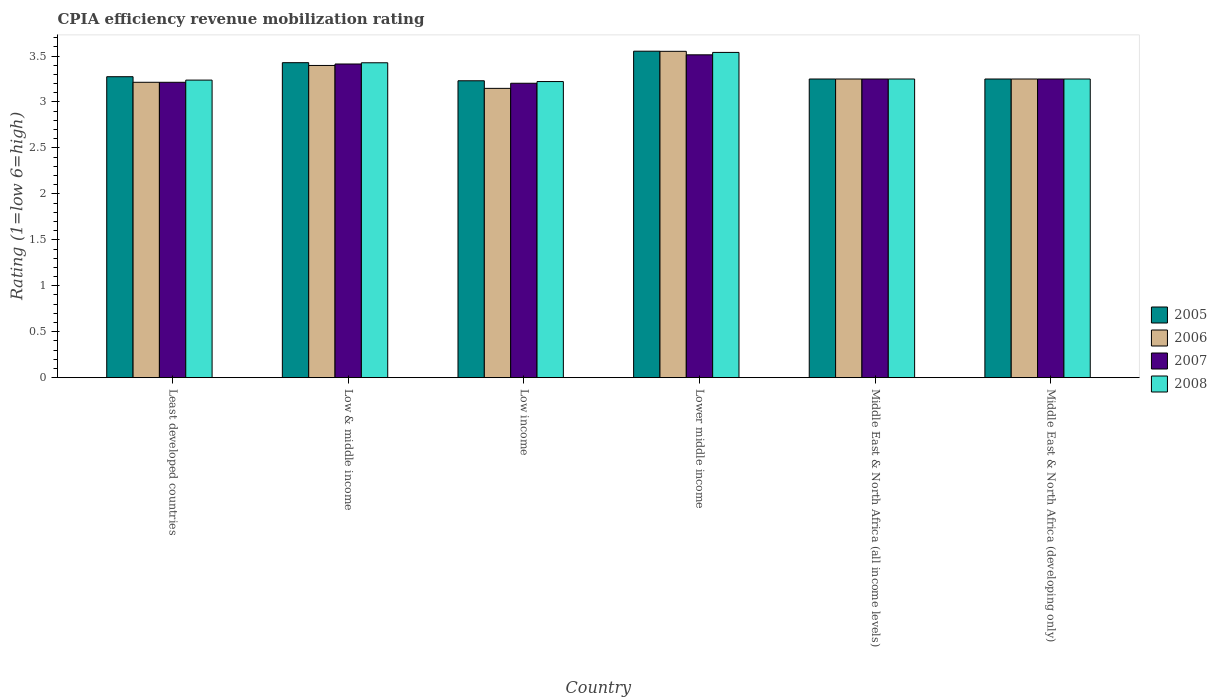How many different coloured bars are there?
Your response must be concise. 4. How many groups of bars are there?
Ensure brevity in your answer.  6. How many bars are there on the 4th tick from the left?
Provide a short and direct response. 4. What is the label of the 5th group of bars from the left?
Your answer should be very brief. Middle East & North Africa (all income levels). What is the CPIA rating in 2005 in Lower middle income?
Give a very brief answer. 3.55. Across all countries, what is the maximum CPIA rating in 2008?
Give a very brief answer. 3.54. Across all countries, what is the minimum CPIA rating in 2008?
Keep it short and to the point. 3.22. In which country was the CPIA rating in 2007 maximum?
Ensure brevity in your answer.  Lower middle income. What is the total CPIA rating in 2008 in the graph?
Your answer should be very brief. 19.93. What is the difference between the CPIA rating in 2005 in Low income and that in Lower middle income?
Your answer should be very brief. -0.32. What is the difference between the CPIA rating in 2005 in Least developed countries and the CPIA rating in 2008 in Middle East & North Africa (all income levels)?
Give a very brief answer. 0.02. What is the average CPIA rating in 2007 per country?
Provide a short and direct response. 3.31. In how many countries, is the CPIA rating in 2005 greater than 0.6?
Give a very brief answer. 6. What is the ratio of the CPIA rating in 2008 in Least developed countries to that in Lower middle income?
Make the answer very short. 0.91. Is the CPIA rating in 2007 in Low income less than that in Lower middle income?
Your answer should be very brief. Yes. What is the difference between the highest and the second highest CPIA rating in 2006?
Your answer should be very brief. 0.15. What is the difference between the highest and the lowest CPIA rating in 2008?
Your answer should be compact. 0.32. In how many countries, is the CPIA rating in 2008 greater than the average CPIA rating in 2008 taken over all countries?
Provide a succinct answer. 2. Is it the case that in every country, the sum of the CPIA rating in 2008 and CPIA rating in 2007 is greater than the sum of CPIA rating in 2006 and CPIA rating in 2005?
Your answer should be very brief. No. What does the 3rd bar from the left in Least developed countries represents?
Make the answer very short. 2007. Is it the case that in every country, the sum of the CPIA rating in 2008 and CPIA rating in 2007 is greater than the CPIA rating in 2006?
Your response must be concise. Yes. How many countries are there in the graph?
Offer a terse response. 6. Does the graph contain any zero values?
Offer a very short reply. No. How many legend labels are there?
Your answer should be compact. 4. What is the title of the graph?
Your answer should be compact. CPIA efficiency revenue mobilization rating. What is the Rating (1=low 6=high) of 2005 in Least developed countries?
Keep it short and to the point. 3.27. What is the Rating (1=low 6=high) in 2006 in Least developed countries?
Offer a terse response. 3.21. What is the Rating (1=low 6=high) of 2007 in Least developed countries?
Provide a short and direct response. 3.21. What is the Rating (1=low 6=high) in 2008 in Least developed countries?
Provide a succinct answer. 3.24. What is the Rating (1=low 6=high) in 2005 in Low & middle income?
Provide a short and direct response. 3.43. What is the Rating (1=low 6=high) in 2006 in Low & middle income?
Your response must be concise. 3.4. What is the Rating (1=low 6=high) in 2007 in Low & middle income?
Your response must be concise. 3.41. What is the Rating (1=low 6=high) in 2008 in Low & middle income?
Your answer should be very brief. 3.43. What is the Rating (1=low 6=high) in 2005 in Low income?
Offer a terse response. 3.23. What is the Rating (1=low 6=high) in 2006 in Low income?
Give a very brief answer. 3.15. What is the Rating (1=low 6=high) in 2007 in Low income?
Your answer should be compact. 3.2. What is the Rating (1=low 6=high) in 2008 in Low income?
Provide a short and direct response. 3.22. What is the Rating (1=low 6=high) of 2005 in Lower middle income?
Your answer should be compact. 3.55. What is the Rating (1=low 6=high) of 2006 in Lower middle income?
Your answer should be compact. 3.55. What is the Rating (1=low 6=high) in 2007 in Lower middle income?
Provide a succinct answer. 3.51. What is the Rating (1=low 6=high) in 2008 in Lower middle income?
Ensure brevity in your answer.  3.54. What is the Rating (1=low 6=high) in 2005 in Middle East & North Africa (all income levels)?
Provide a succinct answer. 3.25. What is the Rating (1=low 6=high) of 2006 in Middle East & North Africa (all income levels)?
Ensure brevity in your answer.  3.25. What is the Rating (1=low 6=high) in 2007 in Middle East & North Africa (all income levels)?
Keep it short and to the point. 3.25. What is the Rating (1=low 6=high) of 2007 in Middle East & North Africa (developing only)?
Offer a very short reply. 3.25. Across all countries, what is the maximum Rating (1=low 6=high) of 2005?
Your response must be concise. 3.55. Across all countries, what is the maximum Rating (1=low 6=high) of 2006?
Ensure brevity in your answer.  3.55. Across all countries, what is the maximum Rating (1=low 6=high) in 2007?
Provide a succinct answer. 3.51. Across all countries, what is the maximum Rating (1=low 6=high) of 2008?
Give a very brief answer. 3.54. Across all countries, what is the minimum Rating (1=low 6=high) in 2005?
Your answer should be compact. 3.23. Across all countries, what is the minimum Rating (1=low 6=high) of 2006?
Your response must be concise. 3.15. Across all countries, what is the minimum Rating (1=low 6=high) of 2007?
Ensure brevity in your answer.  3.2. Across all countries, what is the minimum Rating (1=low 6=high) of 2008?
Keep it short and to the point. 3.22. What is the total Rating (1=low 6=high) of 2005 in the graph?
Give a very brief answer. 19.99. What is the total Rating (1=low 6=high) in 2006 in the graph?
Your answer should be compact. 19.81. What is the total Rating (1=low 6=high) of 2007 in the graph?
Give a very brief answer. 19.84. What is the total Rating (1=low 6=high) of 2008 in the graph?
Provide a short and direct response. 19.93. What is the difference between the Rating (1=low 6=high) of 2005 in Least developed countries and that in Low & middle income?
Your response must be concise. -0.15. What is the difference between the Rating (1=low 6=high) in 2006 in Least developed countries and that in Low & middle income?
Give a very brief answer. -0.18. What is the difference between the Rating (1=low 6=high) of 2007 in Least developed countries and that in Low & middle income?
Provide a short and direct response. -0.2. What is the difference between the Rating (1=low 6=high) of 2008 in Least developed countries and that in Low & middle income?
Ensure brevity in your answer.  -0.19. What is the difference between the Rating (1=low 6=high) in 2005 in Least developed countries and that in Low income?
Provide a succinct answer. 0.04. What is the difference between the Rating (1=low 6=high) of 2006 in Least developed countries and that in Low income?
Provide a short and direct response. 0.07. What is the difference between the Rating (1=low 6=high) of 2007 in Least developed countries and that in Low income?
Ensure brevity in your answer.  0.01. What is the difference between the Rating (1=low 6=high) in 2008 in Least developed countries and that in Low income?
Your response must be concise. 0.02. What is the difference between the Rating (1=low 6=high) in 2005 in Least developed countries and that in Lower middle income?
Offer a terse response. -0.28. What is the difference between the Rating (1=low 6=high) of 2006 in Least developed countries and that in Lower middle income?
Your response must be concise. -0.34. What is the difference between the Rating (1=low 6=high) in 2007 in Least developed countries and that in Lower middle income?
Your response must be concise. -0.3. What is the difference between the Rating (1=low 6=high) in 2008 in Least developed countries and that in Lower middle income?
Offer a terse response. -0.3. What is the difference between the Rating (1=low 6=high) of 2005 in Least developed countries and that in Middle East & North Africa (all income levels)?
Provide a succinct answer. 0.03. What is the difference between the Rating (1=low 6=high) in 2006 in Least developed countries and that in Middle East & North Africa (all income levels)?
Keep it short and to the point. -0.04. What is the difference between the Rating (1=low 6=high) in 2007 in Least developed countries and that in Middle East & North Africa (all income levels)?
Your answer should be compact. -0.04. What is the difference between the Rating (1=low 6=high) in 2008 in Least developed countries and that in Middle East & North Africa (all income levels)?
Ensure brevity in your answer.  -0.01. What is the difference between the Rating (1=low 6=high) in 2005 in Least developed countries and that in Middle East & North Africa (developing only)?
Provide a short and direct response. 0.03. What is the difference between the Rating (1=low 6=high) in 2006 in Least developed countries and that in Middle East & North Africa (developing only)?
Make the answer very short. -0.04. What is the difference between the Rating (1=low 6=high) in 2007 in Least developed countries and that in Middle East & North Africa (developing only)?
Make the answer very short. -0.04. What is the difference between the Rating (1=low 6=high) in 2008 in Least developed countries and that in Middle East & North Africa (developing only)?
Keep it short and to the point. -0.01. What is the difference between the Rating (1=low 6=high) in 2005 in Low & middle income and that in Low income?
Your response must be concise. 0.2. What is the difference between the Rating (1=low 6=high) of 2006 in Low & middle income and that in Low income?
Give a very brief answer. 0.25. What is the difference between the Rating (1=low 6=high) of 2007 in Low & middle income and that in Low income?
Provide a succinct answer. 0.21. What is the difference between the Rating (1=low 6=high) of 2008 in Low & middle income and that in Low income?
Provide a succinct answer. 0.2. What is the difference between the Rating (1=low 6=high) in 2005 in Low & middle income and that in Lower middle income?
Your answer should be very brief. -0.12. What is the difference between the Rating (1=low 6=high) of 2006 in Low & middle income and that in Lower middle income?
Provide a short and direct response. -0.15. What is the difference between the Rating (1=low 6=high) in 2007 in Low & middle income and that in Lower middle income?
Offer a terse response. -0.1. What is the difference between the Rating (1=low 6=high) of 2008 in Low & middle income and that in Lower middle income?
Ensure brevity in your answer.  -0.11. What is the difference between the Rating (1=low 6=high) in 2005 in Low & middle income and that in Middle East & North Africa (all income levels)?
Keep it short and to the point. 0.18. What is the difference between the Rating (1=low 6=high) of 2006 in Low & middle income and that in Middle East & North Africa (all income levels)?
Keep it short and to the point. 0.15. What is the difference between the Rating (1=low 6=high) in 2007 in Low & middle income and that in Middle East & North Africa (all income levels)?
Your response must be concise. 0.16. What is the difference between the Rating (1=low 6=high) in 2008 in Low & middle income and that in Middle East & North Africa (all income levels)?
Your response must be concise. 0.18. What is the difference between the Rating (1=low 6=high) of 2005 in Low & middle income and that in Middle East & North Africa (developing only)?
Ensure brevity in your answer.  0.18. What is the difference between the Rating (1=low 6=high) in 2006 in Low & middle income and that in Middle East & North Africa (developing only)?
Provide a short and direct response. 0.15. What is the difference between the Rating (1=low 6=high) of 2007 in Low & middle income and that in Middle East & North Africa (developing only)?
Make the answer very short. 0.16. What is the difference between the Rating (1=low 6=high) of 2008 in Low & middle income and that in Middle East & North Africa (developing only)?
Offer a terse response. 0.18. What is the difference between the Rating (1=low 6=high) of 2005 in Low income and that in Lower middle income?
Keep it short and to the point. -0.32. What is the difference between the Rating (1=low 6=high) in 2006 in Low income and that in Lower middle income?
Give a very brief answer. -0.4. What is the difference between the Rating (1=low 6=high) in 2007 in Low income and that in Lower middle income?
Make the answer very short. -0.31. What is the difference between the Rating (1=low 6=high) in 2008 in Low income and that in Lower middle income?
Your answer should be compact. -0.32. What is the difference between the Rating (1=low 6=high) in 2005 in Low income and that in Middle East & North Africa (all income levels)?
Provide a succinct answer. -0.02. What is the difference between the Rating (1=low 6=high) of 2006 in Low income and that in Middle East & North Africa (all income levels)?
Your answer should be very brief. -0.1. What is the difference between the Rating (1=low 6=high) of 2007 in Low income and that in Middle East & North Africa (all income levels)?
Provide a succinct answer. -0.05. What is the difference between the Rating (1=low 6=high) in 2008 in Low income and that in Middle East & North Africa (all income levels)?
Your response must be concise. -0.03. What is the difference between the Rating (1=low 6=high) of 2005 in Low income and that in Middle East & North Africa (developing only)?
Ensure brevity in your answer.  -0.02. What is the difference between the Rating (1=low 6=high) of 2006 in Low income and that in Middle East & North Africa (developing only)?
Provide a short and direct response. -0.1. What is the difference between the Rating (1=low 6=high) in 2007 in Low income and that in Middle East & North Africa (developing only)?
Your answer should be compact. -0.05. What is the difference between the Rating (1=low 6=high) in 2008 in Low income and that in Middle East & North Africa (developing only)?
Make the answer very short. -0.03. What is the difference between the Rating (1=low 6=high) in 2005 in Lower middle income and that in Middle East & North Africa (all income levels)?
Your response must be concise. 0.3. What is the difference between the Rating (1=low 6=high) in 2006 in Lower middle income and that in Middle East & North Africa (all income levels)?
Make the answer very short. 0.3. What is the difference between the Rating (1=low 6=high) in 2007 in Lower middle income and that in Middle East & North Africa (all income levels)?
Offer a very short reply. 0.26. What is the difference between the Rating (1=low 6=high) in 2008 in Lower middle income and that in Middle East & North Africa (all income levels)?
Your response must be concise. 0.29. What is the difference between the Rating (1=low 6=high) of 2005 in Lower middle income and that in Middle East & North Africa (developing only)?
Your response must be concise. 0.3. What is the difference between the Rating (1=low 6=high) in 2006 in Lower middle income and that in Middle East & North Africa (developing only)?
Your answer should be very brief. 0.3. What is the difference between the Rating (1=low 6=high) of 2007 in Lower middle income and that in Middle East & North Africa (developing only)?
Give a very brief answer. 0.26. What is the difference between the Rating (1=low 6=high) of 2008 in Lower middle income and that in Middle East & North Africa (developing only)?
Your answer should be compact. 0.29. What is the difference between the Rating (1=low 6=high) in 2005 in Middle East & North Africa (all income levels) and that in Middle East & North Africa (developing only)?
Give a very brief answer. 0. What is the difference between the Rating (1=low 6=high) in 2006 in Middle East & North Africa (all income levels) and that in Middle East & North Africa (developing only)?
Provide a succinct answer. 0. What is the difference between the Rating (1=low 6=high) in 2008 in Middle East & North Africa (all income levels) and that in Middle East & North Africa (developing only)?
Your response must be concise. 0. What is the difference between the Rating (1=low 6=high) of 2005 in Least developed countries and the Rating (1=low 6=high) of 2006 in Low & middle income?
Make the answer very short. -0.12. What is the difference between the Rating (1=low 6=high) in 2005 in Least developed countries and the Rating (1=low 6=high) in 2007 in Low & middle income?
Keep it short and to the point. -0.14. What is the difference between the Rating (1=low 6=high) of 2005 in Least developed countries and the Rating (1=low 6=high) of 2008 in Low & middle income?
Provide a succinct answer. -0.15. What is the difference between the Rating (1=low 6=high) in 2006 in Least developed countries and the Rating (1=low 6=high) in 2007 in Low & middle income?
Make the answer very short. -0.2. What is the difference between the Rating (1=low 6=high) in 2006 in Least developed countries and the Rating (1=low 6=high) in 2008 in Low & middle income?
Make the answer very short. -0.21. What is the difference between the Rating (1=low 6=high) of 2007 in Least developed countries and the Rating (1=low 6=high) of 2008 in Low & middle income?
Offer a very short reply. -0.21. What is the difference between the Rating (1=low 6=high) of 2005 in Least developed countries and the Rating (1=low 6=high) of 2006 in Low income?
Your answer should be very brief. 0.13. What is the difference between the Rating (1=low 6=high) in 2005 in Least developed countries and the Rating (1=low 6=high) in 2007 in Low income?
Give a very brief answer. 0.07. What is the difference between the Rating (1=low 6=high) in 2005 in Least developed countries and the Rating (1=low 6=high) in 2008 in Low income?
Offer a very short reply. 0.05. What is the difference between the Rating (1=low 6=high) of 2006 in Least developed countries and the Rating (1=low 6=high) of 2007 in Low income?
Your answer should be very brief. 0.01. What is the difference between the Rating (1=low 6=high) of 2006 in Least developed countries and the Rating (1=low 6=high) of 2008 in Low income?
Your answer should be compact. -0.01. What is the difference between the Rating (1=low 6=high) of 2007 in Least developed countries and the Rating (1=low 6=high) of 2008 in Low income?
Your answer should be very brief. -0.01. What is the difference between the Rating (1=low 6=high) of 2005 in Least developed countries and the Rating (1=low 6=high) of 2006 in Lower middle income?
Provide a succinct answer. -0.28. What is the difference between the Rating (1=low 6=high) in 2005 in Least developed countries and the Rating (1=low 6=high) in 2007 in Lower middle income?
Offer a very short reply. -0.24. What is the difference between the Rating (1=low 6=high) in 2005 in Least developed countries and the Rating (1=low 6=high) in 2008 in Lower middle income?
Your answer should be compact. -0.26. What is the difference between the Rating (1=low 6=high) in 2006 in Least developed countries and the Rating (1=low 6=high) in 2007 in Lower middle income?
Your answer should be very brief. -0.3. What is the difference between the Rating (1=low 6=high) of 2006 in Least developed countries and the Rating (1=low 6=high) of 2008 in Lower middle income?
Offer a very short reply. -0.33. What is the difference between the Rating (1=low 6=high) in 2007 in Least developed countries and the Rating (1=low 6=high) in 2008 in Lower middle income?
Offer a very short reply. -0.33. What is the difference between the Rating (1=low 6=high) of 2005 in Least developed countries and the Rating (1=low 6=high) of 2006 in Middle East & North Africa (all income levels)?
Offer a very short reply. 0.03. What is the difference between the Rating (1=low 6=high) in 2005 in Least developed countries and the Rating (1=low 6=high) in 2007 in Middle East & North Africa (all income levels)?
Offer a very short reply. 0.03. What is the difference between the Rating (1=low 6=high) of 2005 in Least developed countries and the Rating (1=low 6=high) of 2008 in Middle East & North Africa (all income levels)?
Your response must be concise. 0.03. What is the difference between the Rating (1=low 6=high) of 2006 in Least developed countries and the Rating (1=low 6=high) of 2007 in Middle East & North Africa (all income levels)?
Provide a short and direct response. -0.04. What is the difference between the Rating (1=low 6=high) of 2006 in Least developed countries and the Rating (1=low 6=high) of 2008 in Middle East & North Africa (all income levels)?
Offer a very short reply. -0.04. What is the difference between the Rating (1=low 6=high) of 2007 in Least developed countries and the Rating (1=low 6=high) of 2008 in Middle East & North Africa (all income levels)?
Provide a succinct answer. -0.04. What is the difference between the Rating (1=low 6=high) of 2005 in Least developed countries and the Rating (1=low 6=high) of 2006 in Middle East & North Africa (developing only)?
Your answer should be very brief. 0.03. What is the difference between the Rating (1=low 6=high) of 2005 in Least developed countries and the Rating (1=low 6=high) of 2007 in Middle East & North Africa (developing only)?
Ensure brevity in your answer.  0.03. What is the difference between the Rating (1=low 6=high) in 2005 in Least developed countries and the Rating (1=low 6=high) in 2008 in Middle East & North Africa (developing only)?
Offer a very short reply. 0.03. What is the difference between the Rating (1=low 6=high) of 2006 in Least developed countries and the Rating (1=low 6=high) of 2007 in Middle East & North Africa (developing only)?
Your answer should be very brief. -0.04. What is the difference between the Rating (1=low 6=high) in 2006 in Least developed countries and the Rating (1=low 6=high) in 2008 in Middle East & North Africa (developing only)?
Ensure brevity in your answer.  -0.04. What is the difference between the Rating (1=low 6=high) of 2007 in Least developed countries and the Rating (1=low 6=high) of 2008 in Middle East & North Africa (developing only)?
Keep it short and to the point. -0.04. What is the difference between the Rating (1=low 6=high) of 2005 in Low & middle income and the Rating (1=low 6=high) of 2006 in Low income?
Your response must be concise. 0.28. What is the difference between the Rating (1=low 6=high) in 2005 in Low & middle income and the Rating (1=low 6=high) in 2007 in Low income?
Make the answer very short. 0.22. What is the difference between the Rating (1=low 6=high) in 2005 in Low & middle income and the Rating (1=low 6=high) in 2008 in Low income?
Offer a terse response. 0.21. What is the difference between the Rating (1=low 6=high) in 2006 in Low & middle income and the Rating (1=low 6=high) in 2007 in Low income?
Provide a short and direct response. 0.19. What is the difference between the Rating (1=low 6=high) of 2006 in Low & middle income and the Rating (1=low 6=high) of 2008 in Low income?
Make the answer very short. 0.18. What is the difference between the Rating (1=low 6=high) of 2007 in Low & middle income and the Rating (1=low 6=high) of 2008 in Low income?
Your response must be concise. 0.19. What is the difference between the Rating (1=low 6=high) of 2005 in Low & middle income and the Rating (1=low 6=high) of 2006 in Lower middle income?
Keep it short and to the point. -0.12. What is the difference between the Rating (1=low 6=high) in 2005 in Low & middle income and the Rating (1=low 6=high) in 2007 in Lower middle income?
Your answer should be very brief. -0.09. What is the difference between the Rating (1=low 6=high) in 2005 in Low & middle income and the Rating (1=low 6=high) in 2008 in Lower middle income?
Your answer should be very brief. -0.11. What is the difference between the Rating (1=low 6=high) in 2006 in Low & middle income and the Rating (1=low 6=high) in 2007 in Lower middle income?
Keep it short and to the point. -0.12. What is the difference between the Rating (1=low 6=high) of 2006 in Low & middle income and the Rating (1=low 6=high) of 2008 in Lower middle income?
Offer a terse response. -0.14. What is the difference between the Rating (1=low 6=high) of 2007 in Low & middle income and the Rating (1=low 6=high) of 2008 in Lower middle income?
Make the answer very short. -0.13. What is the difference between the Rating (1=low 6=high) in 2005 in Low & middle income and the Rating (1=low 6=high) in 2006 in Middle East & North Africa (all income levels)?
Your answer should be compact. 0.18. What is the difference between the Rating (1=low 6=high) of 2005 in Low & middle income and the Rating (1=low 6=high) of 2007 in Middle East & North Africa (all income levels)?
Keep it short and to the point. 0.18. What is the difference between the Rating (1=low 6=high) of 2005 in Low & middle income and the Rating (1=low 6=high) of 2008 in Middle East & North Africa (all income levels)?
Your answer should be compact. 0.18. What is the difference between the Rating (1=low 6=high) in 2006 in Low & middle income and the Rating (1=low 6=high) in 2007 in Middle East & North Africa (all income levels)?
Offer a terse response. 0.15. What is the difference between the Rating (1=low 6=high) in 2006 in Low & middle income and the Rating (1=low 6=high) in 2008 in Middle East & North Africa (all income levels)?
Offer a very short reply. 0.15. What is the difference between the Rating (1=low 6=high) of 2007 in Low & middle income and the Rating (1=low 6=high) of 2008 in Middle East & North Africa (all income levels)?
Offer a terse response. 0.16. What is the difference between the Rating (1=low 6=high) in 2005 in Low & middle income and the Rating (1=low 6=high) in 2006 in Middle East & North Africa (developing only)?
Your response must be concise. 0.18. What is the difference between the Rating (1=low 6=high) of 2005 in Low & middle income and the Rating (1=low 6=high) of 2007 in Middle East & North Africa (developing only)?
Offer a very short reply. 0.18. What is the difference between the Rating (1=low 6=high) of 2005 in Low & middle income and the Rating (1=low 6=high) of 2008 in Middle East & North Africa (developing only)?
Offer a terse response. 0.18. What is the difference between the Rating (1=low 6=high) of 2006 in Low & middle income and the Rating (1=low 6=high) of 2007 in Middle East & North Africa (developing only)?
Offer a terse response. 0.15. What is the difference between the Rating (1=low 6=high) of 2006 in Low & middle income and the Rating (1=low 6=high) of 2008 in Middle East & North Africa (developing only)?
Your answer should be compact. 0.15. What is the difference between the Rating (1=low 6=high) in 2007 in Low & middle income and the Rating (1=low 6=high) in 2008 in Middle East & North Africa (developing only)?
Offer a terse response. 0.16. What is the difference between the Rating (1=low 6=high) of 2005 in Low income and the Rating (1=low 6=high) of 2006 in Lower middle income?
Provide a succinct answer. -0.32. What is the difference between the Rating (1=low 6=high) in 2005 in Low income and the Rating (1=low 6=high) in 2007 in Lower middle income?
Your response must be concise. -0.28. What is the difference between the Rating (1=low 6=high) of 2005 in Low income and the Rating (1=low 6=high) of 2008 in Lower middle income?
Ensure brevity in your answer.  -0.31. What is the difference between the Rating (1=low 6=high) of 2006 in Low income and the Rating (1=low 6=high) of 2007 in Lower middle income?
Give a very brief answer. -0.36. What is the difference between the Rating (1=low 6=high) of 2006 in Low income and the Rating (1=low 6=high) of 2008 in Lower middle income?
Offer a terse response. -0.39. What is the difference between the Rating (1=low 6=high) in 2007 in Low income and the Rating (1=low 6=high) in 2008 in Lower middle income?
Provide a short and direct response. -0.34. What is the difference between the Rating (1=low 6=high) in 2005 in Low income and the Rating (1=low 6=high) in 2006 in Middle East & North Africa (all income levels)?
Offer a very short reply. -0.02. What is the difference between the Rating (1=low 6=high) of 2005 in Low income and the Rating (1=low 6=high) of 2007 in Middle East & North Africa (all income levels)?
Keep it short and to the point. -0.02. What is the difference between the Rating (1=low 6=high) in 2005 in Low income and the Rating (1=low 6=high) in 2008 in Middle East & North Africa (all income levels)?
Make the answer very short. -0.02. What is the difference between the Rating (1=low 6=high) in 2006 in Low income and the Rating (1=low 6=high) in 2007 in Middle East & North Africa (all income levels)?
Give a very brief answer. -0.1. What is the difference between the Rating (1=low 6=high) in 2006 in Low income and the Rating (1=low 6=high) in 2008 in Middle East & North Africa (all income levels)?
Offer a terse response. -0.1. What is the difference between the Rating (1=low 6=high) of 2007 in Low income and the Rating (1=low 6=high) of 2008 in Middle East & North Africa (all income levels)?
Provide a succinct answer. -0.05. What is the difference between the Rating (1=low 6=high) in 2005 in Low income and the Rating (1=low 6=high) in 2006 in Middle East & North Africa (developing only)?
Ensure brevity in your answer.  -0.02. What is the difference between the Rating (1=low 6=high) in 2005 in Low income and the Rating (1=low 6=high) in 2007 in Middle East & North Africa (developing only)?
Offer a very short reply. -0.02. What is the difference between the Rating (1=low 6=high) in 2005 in Low income and the Rating (1=low 6=high) in 2008 in Middle East & North Africa (developing only)?
Make the answer very short. -0.02. What is the difference between the Rating (1=low 6=high) in 2006 in Low income and the Rating (1=low 6=high) in 2007 in Middle East & North Africa (developing only)?
Offer a very short reply. -0.1. What is the difference between the Rating (1=low 6=high) of 2006 in Low income and the Rating (1=low 6=high) of 2008 in Middle East & North Africa (developing only)?
Give a very brief answer. -0.1. What is the difference between the Rating (1=low 6=high) in 2007 in Low income and the Rating (1=low 6=high) in 2008 in Middle East & North Africa (developing only)?
Provide a succinct answer. -0.05. What is the difference between the Rating (1=low 6=high) in 2005 in Lower middle income and the Rating (1=low 6=high) in 2006 in Middle East & North Africa (all income levels)?
Your response must be concise. 0.3. What is the difference between the Rating (1=low 6=high) of 2005 in Lower middle income and the Rating (1=low 6=high) of 2007 in Middle East & North Africa (all income levels)?
Your answer should be compact. 0.3. What is the difference between the Rating (1=low 6=high) in 2005 in Lower middle income and the Rating (1=low 6=high) in 2008 in Middle East & North Africa (all income levels)?
Offer a terse response. 0.3. What is the difference between the Rating (1=low 6=high) of 2006 in Lower middle income and the Rating (1=low 6=high) of 2007 in Middle East & North Africa (all income levels)?
Give a very brief answer. 0.3. What is the difference between the Rating (1=low 6=high) of 2006 in Lower middle income and the Rating (1=low 6=high) of 2008 in Middle East & North Africa (all income levels)?
Ensure brevity in your answer.  0.3. What is the difference between the Rating (1=low 6=high) in 2007 in Lower middle income and the Rating (1=low 6=high) in 2008 in Middle East & North Africa (all income levels)?
Ensure brevity in your answer.  0.26. What is the difference between the Rating (1=low 6=high) in 2005 in Lower middle income and the Rating (1=low 6=high) in 2006 in Middle East & North Africa (developing only)?
Provide a succinct answer. 0.3. What is the difference between the Rating (1=low 6=high) in 2005 in Lower middle income and the Rating (1=low 6=high) in 2007 in Middle East & North Africa (developing only)?
Provide a succinct answer. 0.3. What is the difference between the Rating (1=low 6=high) in 2005 in Lower middle income and the Rating (1=low 6=high) in 2008 in Middle East & North Africa (developing only)?
Keep it short and to the point. 0.3. What is the difference between the Rating (1=low 6=high) of 2006 in Lower middle income and the Rating (1=low 6=high) of 2007 in Middle East & North Africa (developing only)?
Keep it short and to the point. 0.3. What is the difference between the Rating (1=low 6=high) in 2006 in Lower middle income and the Rating (1=low 6=high) in 2008 in Middle East & North Africa (developing only)?
Make the answer very short. 0.3. What is the difference between the Rating (1=low 6=high) in 2007 in Lower middle income and the Rating (1=low 6=high) in 2008 in Middle East & North Africa (developing only)?
Ensure brevity in your answer.  0.26. What is the difference between the Rating (1=low 6=high) in 2005 in Middle East & North Africa (all income levels) and the Rating (1=low 6=high) in 2006 in Middle East & North Africa (developing only)?
Your answer should be very brief. 0. What is the difference between the Rating (1=low 6=high) of 2006 in Middle East & North Africa (all income levels) and the Rating (1=low 6=high) of 2008 in Middle East & North Africa (developing only)?
Your response must be concise. 0. What is the average Rating (1=low 6=high) of 2005 per country?
Offer a terse response. 3.33. What is the average Rating (1=low 6=high) of 2006 per country?
Your answer should be compact. 3.3. What is the average Rating (1=low 6=high) of 2007 per country?
Ensure brevity in your answer.  3.31. What is the average Rating (1=low 6=high) in 2008 per country?
Provide a short and direct response. 3.32. What is the difference between the Rating (1=low 6=high) in 2005 and Rating (1=low 6=high) in 2006 in Least developed countries?
Keep it short and to the point. 0.06. What is the difference between the Rating (1=low 6=high) of 2005 and Rating (1=low 6=high) of 2007 in Least developed countries?
Provide a short and direct response. 0.06. What is the difference between the Rating (1=low 6=high) in 2005 and Rating (1=low 6=high) in 2008 in Least developed countries?
Provide a succinct answer. 0.04. What is the difference between the Rating (1=low 6=high) in 2006 and Rating (1=low 6=high) in 2008 in Least developed countries?
Your answer should be compact. -0.02. What is the difference between the Rating (1=low 6=high) in 2007 and Rating (1=low 6=high) in 2008 in Least developed countries?
Provide a short and direct response. -0.02. What is the difference between the Rating (1=low 6=high) in 2005 and Rating (1=low 6=high) in 2006 in Low & middle income?
Offer a very short reply. 0.03. What is the difference between the Rating (1=low 6=high) of 2005 and Rating (1=low 6=high) of 2007 in Low & middle income?
Ensure brevity in your answer.  0.01. What is the difference between the Rating (1=low 6=high) of 2006 and Rating (1=low 6=high) of 2007 in Low & middle income?
Make the answer very short. -0.02. What is the difference between the Rating (1=low 6=high) in 2006 and Rating (1=low 6=high) in 2008 in Low & middle income?
Ensure brevity in your answer.  -0.03. What is the difference between the Rating (1=low 6=high) in 2007 and Rating (1=low 6=high) in 2008 in Low & middle income?
Give a very brief answer. -0.01. What is the difference between the Rating (1=low 6=high) of 2005 and Rating (1=low 6=high) of 2006 in Low income?
Provide a short and direct response. 0.08. What is the difference between the Rating (1=low 6=high) of 2005 and Rating (1=low 6=high) of 2007 in Low income?
Ensure brevity in your answer.  0.03. What is the difference between the Rating (1=low 6=high) in 2005 and Rating (1=low 6=high) in 2008 in Low income?
Give a very brief answer. 0.01. What is the difference between the Rating (1=low 6=high) in 2006 and Rating (1=low 6=high) in 2007 in Low income?
Provide a succinct answer. -0.06. What is the difference between the Rating (1=low 6=high) of 2006 and Rating (1=low 6=high) of 2008 in Low income?
Provide a succinct answer. -0.07. What is the difference between the Rating (1=low 6=high) of 2007 and Rating (1=low 6=high) of 2008 in Low income?
Offer a terse response. -0.02. What is the difference between the Rating (1=low 6=high) in 2005 and Rating (1=low 6=high) in 2006 in Lower middle income?
Provide a short and direct response. 0. What is the difference between the Rating (1=low 6=high) in 2005 and Rating (1=low 6=high) in 2007 in Lower middle income?
Your response must be concise. 0.04. What is the difference between the Rating (1=low 6=high) in 2005 and Rating (1=low 6=high) in 2008 in Lower middle income?
Give a very brief answer. 0.01. What is the difference between the Rating (1=low 6=high) of 2006 and Rating (1=low 6=high) of 2007 in Lower middle income?
Offer a terse response. 0.04. What is the difference between the Rating (1=low 6=high) of 2006 and Rating (1=low 6=high) of 2008 in Lower middle income?
Ensure brevity in your answer.  0.01. What is the difference between the Rating (1=low 6=high) in 2007 and Rating (1=low 6=high) in 2008 in Lower middle income?
Provide a short and direct response. -0.03. What is the difference between the Rating (1=low 6=high) of 2005 and Rating (1=low 6=high) of 2006 in Middle East & North Africa (all income levels)?
Offer a very short reply. 0. What is the difference between the Rating (1=low 6=high) in 2005 and Rating (1=low 6=high) in 2007 in Middle East & North Africa (all income levels)?
Give a very brief answer. 0. What is the difference between the Rating (1=low 6=high) in 2006 and Rating (1=low 6=high) in 2007 in Middle East & North Africa (all income levels)?
Your response must be concise. 0. What is the ratio of the Rating (1=low 6=high) in 2005 in Least developed countries to that in Low & middle income?
Ensure brevity in your answer.  0.96. What is the ratio of the Rating (1=low 6=high) in 2006 in Least developed countries to that in Low & middle income?
Give a very brief answer. 0.95. What is the ratio of the Rating (1=low 6=high) of 2007 in Least developed countries to that in Low & middle income?
Your response must be concise. 0.94. What is the ratio of the Rating (1=low 6=high) in 2008 in Least developed countries to that in Low & middle income?
Keep it short and to the point. 0.94. What is the ratio of the Rating (1=low 6=high) in 2005 in Least developed countries to that in Low income?
Offer a very short reply. 1.01. What is the ratio of the Rating (1=low 6=high) of 2006 in Least developed countries to that in Low income?
Make the answer very short. 1.02. What is the ratio of the Rating (1=low 6=high) of 2007 in Least developed countries to that in Low income?
Your answer should be very brief. 1. What is the ratio of the Rating (1=low 6=high) of 2008 in Least developed countries to that in Low income?
Provide a short and direct response. 1. What is the ratio of the Rating (1=low 6=high) in 2005 in Least developed countries to that in Lower middle income?
Make the answer very short. 0.92. What is the ratio of the Rating (1=low 6=high) in 2006 in Least developed countries to that in Lower middle income?
Your answer should be very brief. 0.91. What is the ratio of the Rating (1=low 6=high) of 2007 in Least developed countries to that in Lower middle income?
Ensure brevity in your answer.  0.91. What is the ratio of the Rating (1=low 6=high) of 2008 in Least developed countries to that in Lower middle income?
Offer a terse response. 0.91. What is the ratio of the Rating (1=low 6=high) of 2005 in Least developed countries to that in Middle East & North Africa (all income levels)?
Offer a very short reply. 1.01. What is the ratio of the Rating (1=low 6=high) of 2006 in Least developed countries to that in Middle East & North Africa (all income levels)?
Your response must be concise. 0.99. What is the ratio of the Rating (1=low 6=high) of 2008 in Least developed countries to that in Middle East & North Africa (all income levels)?
Your answer should be compact. 1. What is the ratio of the Rating (1=low 6=high) of 2005 in Least developed countries to that in Middle East & North Africa (developing only)?
Give a very brief answer. 1.01. What is the ratio of the Rating (1=low 6=high) of 2008 in Least developed countries to that in Middle East & North Africa (developing only)?
Your answer should be compact. 1. What is the ratio of the Rating (1=low 6=high) in 2005 in Low & middle income to that in Low income?
Ensure brevity in your answer.  1.06. What is the ratio of the Rating (1=low 6=high) in 2006 in Low & middle income to that in Low income?
Your answer should be very brief. 1.08. What is the ratio of the Rating (1=low 6=high) of 2007 in Low & middle income to that in Low income?
Ensure brevity in your answer.  1.07. What is the ratio of the Rating (1=low 6=high) of 2008 in Low & middle income to that in Low income?
Provide a short and direct response. 1.06. What is the ratio of the Rating (1=low 6=high) of 2005 in Low & middle income to that in Lower middle income?
Your response must be concise. 0.96. What is the ratio of the Rating (1=low 6=high) in 2006 in Low & middle income to that in Lower middle income?
Offer a terse response. 0.96. What is the ratio of the Rating (1=low 6=high) in 2007 in Low & middle income to that in Lower middle income?
Provide a short and direct response. 0.97. What is the ratio of the Rating (1=low 6=high) of 2008 in Low & middle income to that in Lower middle income?
Your answer should be compact. 0.97. What is the ratio of the Rating (1=low 6=high) in 2005 in Low & middle income to that in Middle East & North Africa (all income levels)?
Give a very brief answer. 1.05. What is the ratio of the Rating (1=low 6=high) in 2006 in Low & middle income to that in Middle East & North Africa (all income levels)?
Your answer should be very brief. 1.05. What is the ratio of the Rating (1=low 6=high) of 2007 in Low & middle income to that in Middle East & North Africa (all income levels)?
Your answer should be very brief. 1.05. What is the ratio of the Rating (1=low 6=high) in 2008 in Low & middle income to that in Middle East & North Africa (all income levels)?
Provide a succinct answer. 1.05. What is the ratio of the Rating (1=low 6=high) of 2005 in Low & middle income to that in Middle East & North Africa (developing only)?
Keep it short and to the point. 1.05. What is the ratio of the Rating (1=low 6=high) in 2006 in Low & middle income to that in Middle East & North Africa (developing only)?
Your response must be concise. 1.05. What is the ratio of the Rating (1=low 6=high) in 2007 in Low & middle income to that in Middle East & North Africa (developing only)?
Provide a short and direct response. 1.05. What is the ratio of the Rating (1=low 6=high) of 2008 in Low & middle income to that in Middle East & North Africa (developing only)?
Offer a terse response. 1.05. What is the ratio of the Rating (1=low 6=high) in 2005 in Low income to that in Lower middle income?
Make the answer very short. 0.91. What is the ratio of the Rating (1=low 6=high) of 2006 in Low income to that in Lower middle income?
Keep it short and to the point. 0.89. What is the ratio of the Rating (1=low 6=high) in 2007 in Low income to that in Lower middle income?
Provide a succinct answer. 0.91. What is the ratio of the Rating (1=low 6=high) of 2008 in Low income to that in Lower middle income?
Make the answer very short. 0.91. What is the ratio of the Rating (1=low 6=high) in 2005 in Low income to that in Middle East & North Africa (all income levels)?
Offer a terse response. 0.99. What is the ratio of the Rating (1=low 6=high) in 2006 in Low income to that in Middle East & North Africa (all income levels)?
Your answer should be very brief. 0.97. What is the ratio of the Rating (1=low 6=high) in 2007 in Low income to that in Middle East & North Africa (all income levels)?
Offer a very short reply. 0.99. What is the ratio of the Rating (1=low 6=high) of 2008 in Low income to that in Middle East & North Africa (all income levels)?
Give a very brief answer. 0.99. What is the ratio of the Rating (1=low 6=high) in 2005 in Low income to that in Middle East & North Africa (developing only)?
Provide a short and direct response. 0.99. What is the ratio of the Rating (1=low 6=high) in 2006 in Low income to that in Middle East & North Africa (developing only)?
Your answer should be compact. 0.97. What is the ratio of the Rating (1=low 6=high) in 2007 in Low income to that in Middle East & North Africa (developing only)?
Offer a terse response. 0.99. What is the ratio of the Rating (1=low 6=high) of 2005 in Lower middle income to that in Middle East & North Africa (all income levels)?
Give a very brief answer. 1.09. What is the ratio of the Rating (1=low 6=high) of 2006 in Lower middle income to that in Middle East & North Africa (all income levels)?
Ensure brevity in your answer.  1.09. What is the ratio of the Rating (1=low 6=high) of 2007 in Lower middle income to that in Middle East & North Africa (all income levels)?
Provide a succinct answer. 1.08. What is the ratio of the Rating (1=low 6=high) of 2008 in Lower middle income to that in Middle East & North Africa (all income levels)?
Make the answer very short. 1.09. What is the ratio of the Rating (1=low 6=high) of 2005 in Lower middle income to that in Middle East & North Africa (developing only)?
Make the answer very short. 1.09. What is the ratio of the Rating (1=low 6=high) in 2006 in Lower middle income to that in Middle East & North Africa (developing only)?
Ensure brevity in your answer.  1.09. What is the ratio of the Rating (1=low 6=high) of 2007 in Lower middle income to that in Middle East & North Africa (developing only)?
Give a very brief answer. 1.08. What is the ratio of the Rating (1=low 6=high) of 2008 in Lower middle income to that in Middle East & North Africa (developing only)?
Offer a terse response. 1.09. What is the ratio of the Rating (1=low 6=high) of 2006 in Middle East & North Africa (all income levels) to that in Middle East & North Africa (developing only)?
Provide a short and direct response. 1. What is the difference between the highest and the second highest Rating (1=low 6=high) of 2006?
Offer a very short reply. 0.15. What is the difference between the highest and the second highest Rating (1=low 6=high) of 2007?
Provide a short and direct response. 0.1. What is the difference between the highest and the second highest Rating (1=low 6=high) in 2008?
Your answer should be very brief. 0.11. What is the difference between the highest and the lowest Rating (1=low 6=high) of 2005?
Offer a terse response. 0.32. What is the difference between the highest and the lowest Rating (1=low 6=high) of 2006?
Your answer should be compact. 0.4. What is the difference between the highest and the lowest Rating (1=low 6=high) of 2007?
Provide a short and direct response. 0.31. What is the difference between the highest and the lowest Rating (1=low 6=high) of 2008?
Provide a short and direct response. 0.32. 